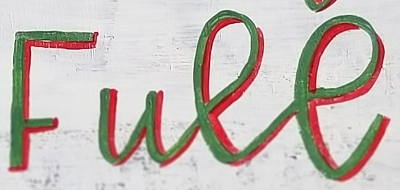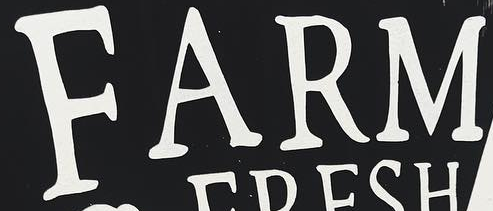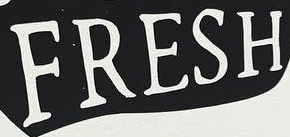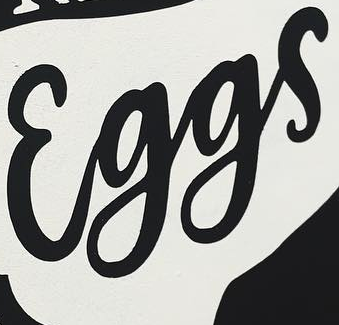Transcribe the words shown in these images in order, separated by a semicolon. Full; FARM; FRESH; Eggs 